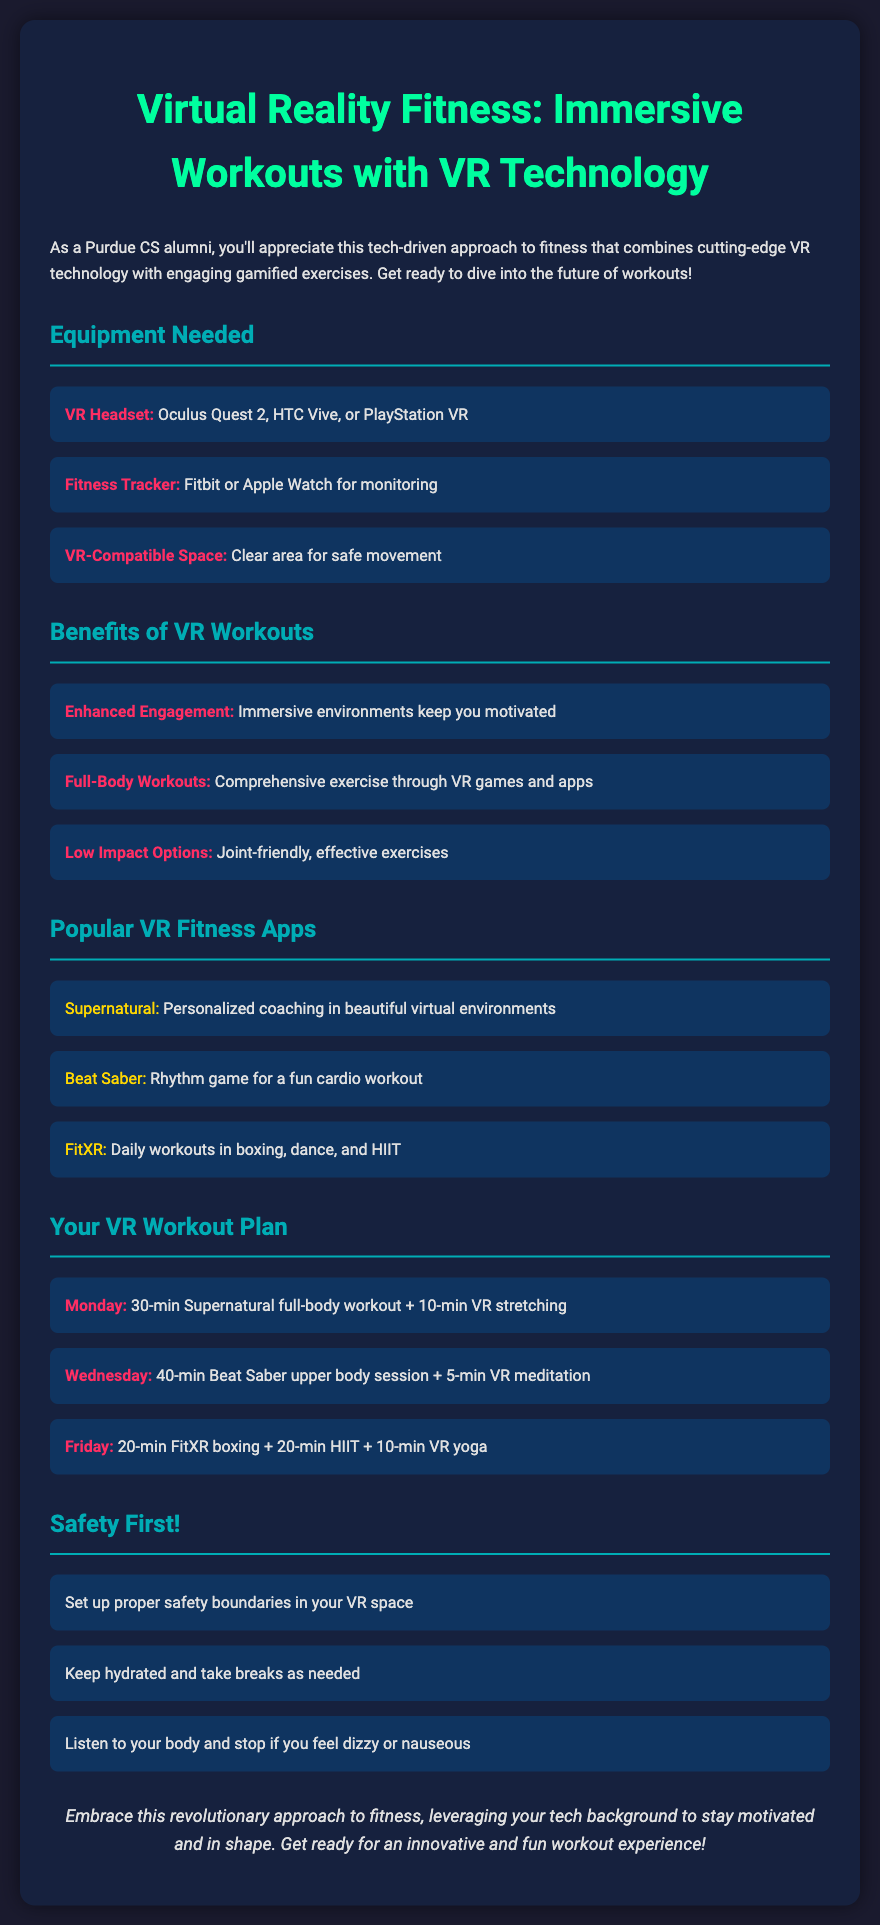What is the title of the document? The title is displayed prominently at the top of the document, which is about VR fitness.
Answer: Virtual Reality Fitness: Immersive Workouts with VR Technology What is one type of VR headset mentioned? The document lists several VR headsets needed for the workouts.
Answer: Oculus Quest 2 Name one benefit of VR workouts. The benefits of VR workouts are outlined in a dedicated section.
Answer: Enhanced Engagement Which app provides personalized coaching? The document lists popular VR fitness apps and their features.
Answer: Supernatural What is scheduled for Monday's workout? The document details a specific workout plan with activities assigned to each day.
Answer: 30-min Supernatural full-body workout + 10-min VR stretching How long is the Beat Saber session on Wednesday? The workout plan specifies the duration of each activity for Wednesday.
Answer: 40-min What is highlighted as a safety precaution? Safety measures are provided in a section dedicated to ensuring safe VR workouts.
Answer: Set up proper safety boundaries in your VR space How many minutes of HIIT are planned for Friday? The workout details the breakdown of exercises planned for Friday.
Answer: 20-min What color is used for highlighting benefits in the document? The specific color used for highlights is mentioned in the styling section.
Answer: #ff2e63 